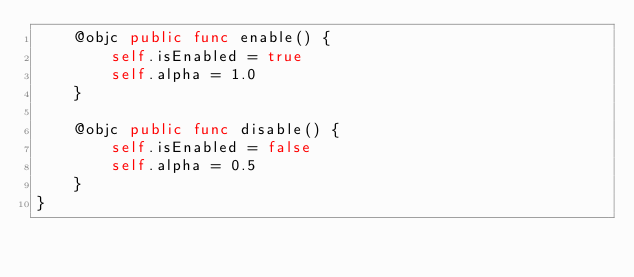<code> <loc_0><loc_0><loc_500><loc_500><_Swift_>    @objc public func enable() {
        self.isEnabled = true
        self.alpha = 1.0
    }

    @objc public func disable() {
        self.isEnabled = false
        self.alpha = 0.5
    }
}
</code> 